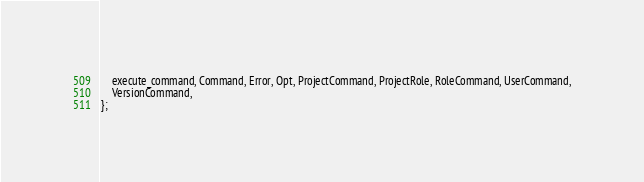Convert code to text. <code><loc_0><loc_0><loc_500><loc_500><_Rust_>    execute_command, Command, Error, Opt, ProjectCommand, ProjectRole, RoleCommand, UserCommand,
    VersionCommand,
};
</code> 